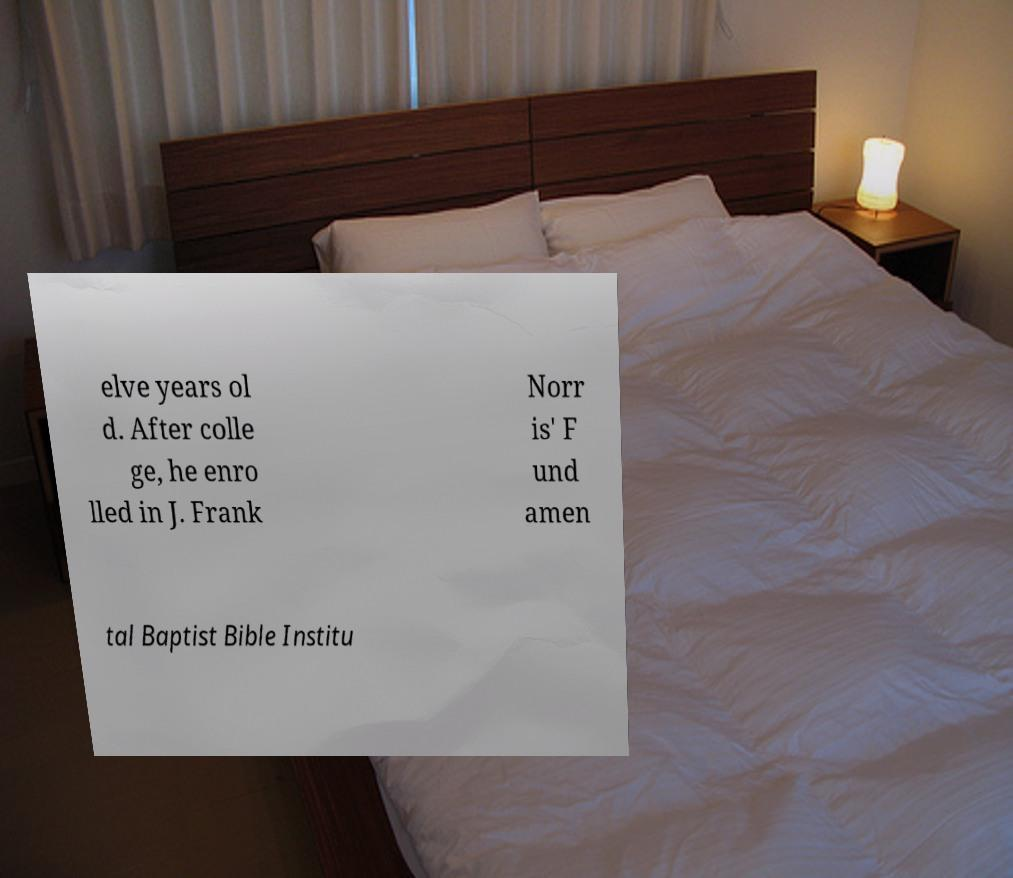I need the written content from this picture converted into text. Can you do that? elve years ol d. After colle ge, he enro lled in J. Frank Norr is' F und amen tal Baptist Bible Institu 